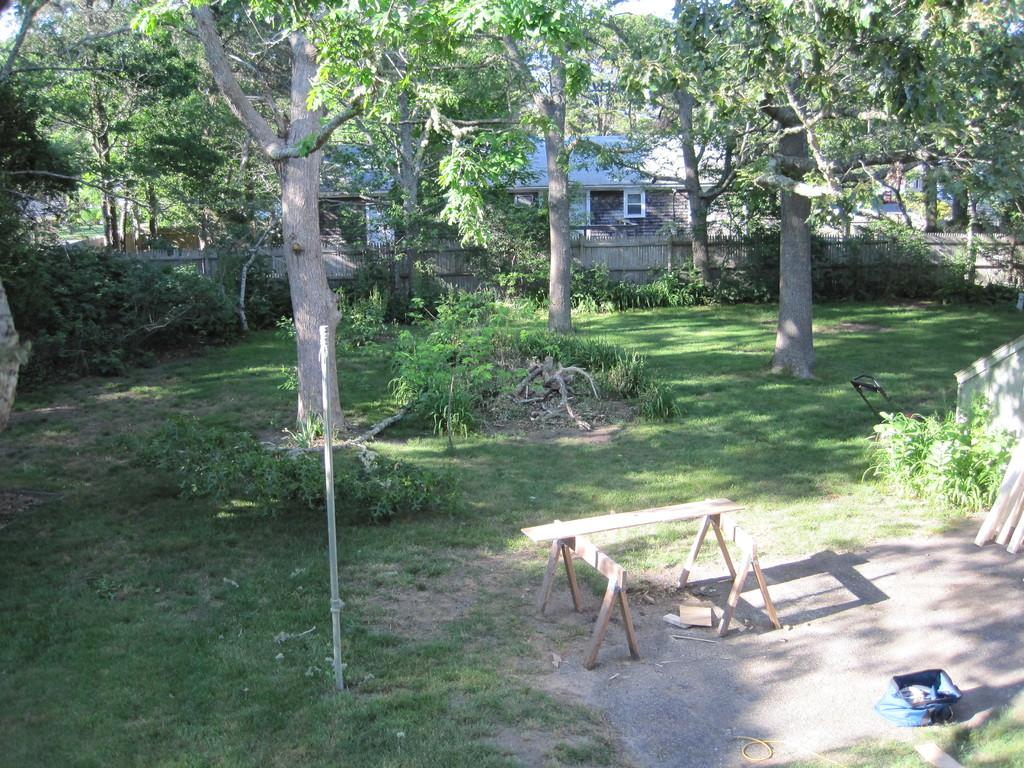What is the main structure in the image? There is a wooden stand in the image. What other object can be seen in the image? There is a pole in the image. What is located on the ground in the image? There is an object on the ground in the image. What can be seen in the background of the image? There are trees, grass, houses, windows, a fence, and the sky visible in the background of the image. How does the cork interact with the wooden stand in the image? There is no cork present in the image, so it cannot interact with the wooden stand. What type of game is being played in the image? There is no game or play activity depicted in the image. 